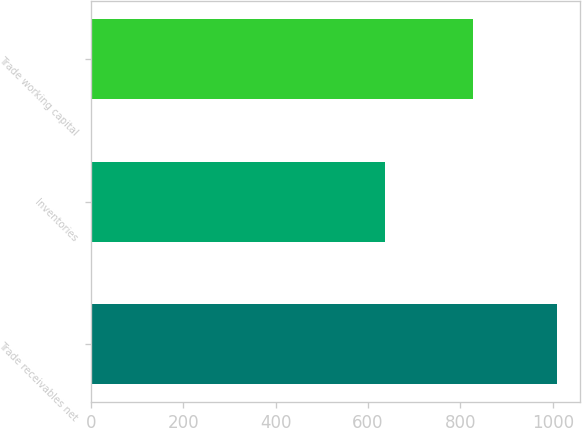Convert chart to OTSL. <chart><loc_0><loc_0><loc_500><loc_500><bar_chart><fcel>Trade receivables net<fcel>Inventories<fcel>Trade working capital<nl><fcel>1009<fcel>636<fcel>827<nl></chart> 